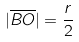Convert formula to latex. <formula><loc_0><loc_0><loc_500><loc_500>| \overline { B O } | = \frac { r } { 2 }</formula> 